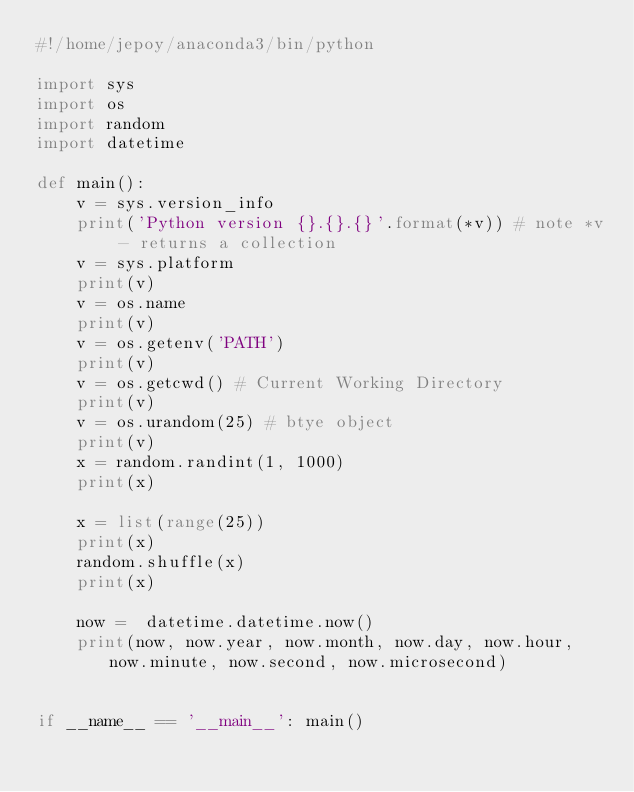<code> <loc_0><loc_0><loc_500><loc_500><_Python_>#!/home/jepoy/anaconda3/bin/python

import sys
import os
import random
import datetime

def main():
    v = sys.version_info
    print('Python version {}.{}.{}'.format(*v)) # note *v - returns a collection
    v = sys.platform
    print(v)
    v = os.name
    print(v)
    v = os.getenv('PATH')
    print(v)
    v = os.getcwd() # Current Working Directory
    print(v)
    v = os.urandom(25) # btye object
    print(v)
    x = random.randint(1, 1000)
    print(x)

    x = list(range(25))
    print(x)
    random.shuffle(x)
    print(x)

    now =  datetime.datetime.now()
    print(now, now.year, now.month, now.day, now.hour, now.minute, now.second, now.microsecond)


if __name__ == '__main__': main()</code> 